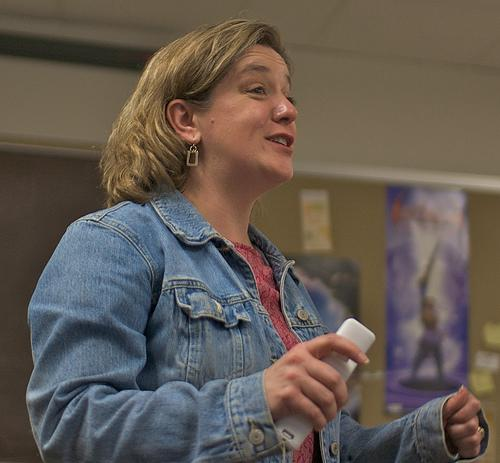Question: who is in the photo?
Choices:
A. A baby.
B. A man.
C. A girl.
D. A woman.
Answer with the letter. Answer: D Question: what is the woman holding?
Choices:
A. Butcher knife.
B. Glass of milk.
C. A Wii remote.
D. Hair brush.
Answer with the letter. Answer: C Question: what color is the remote?
Choices:
A. Silver.
B. White.
C. Black.
D. Grey.
Answer with the letter. Answer: B Question: how many people are there?
Choices:
A. 4.
B. 2.
C. 1.
D. 0.
Answer with the letter. Answer: C Question: what kind of jacket is the woman wearing?
Choices:
A. Leather.
B. Denim.
C. Bomber jacket.
D. Peacoat.
Answer with the letter. Answer: B Question: what is the woman wearing?
Choices:
A. Swim suit.
B. Full length dress.
C. Work out clothes.
D. A shirt and a jean jacket.
Answer with the letter. Answer: D 